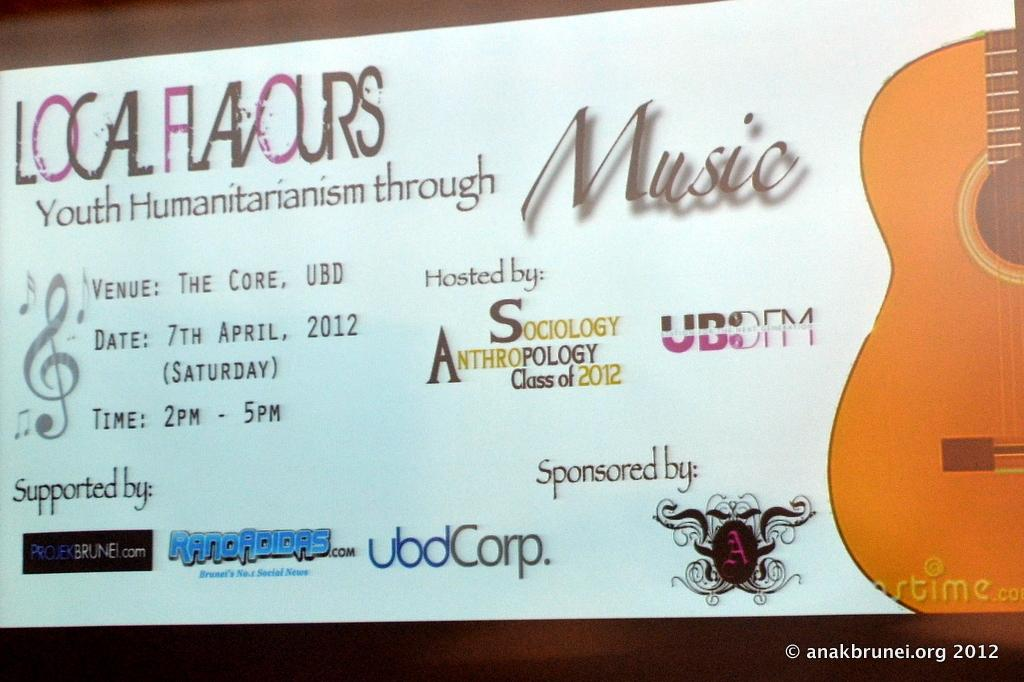What is the main object in the image? There is a ticket pass in the image. What can be found on the ticket pass? There is text and a watermark on the ticket pass. Where is the text located on the ticket pass? There is text in the bottom right corner of the ticket pass. What image is featured on the ticket pass? There is a picture of a guitar on the ticket pass. How does the mist affect the guitar's sound in the image? There is no mist present in the image, and therefore no such effect can be observed. 